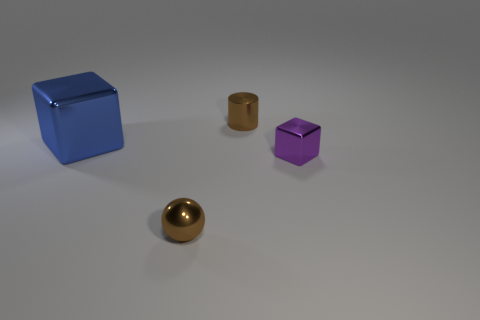Subtract all purple blocks. How many blocks are left? 1 Add 4 purple shiny things. How many objects exist? 8 Subtract all cylinders. How many objects are left? 3 Subtract all tiny balls. Subtract all tiny spheres. How many objects are left? 2 Add 3 purple things. How many purple things are left? 4 Add 4 blue metallic cubes. How many blue metallic cubes exist? 5 Subtract 0 yellow cubes. How many objects are left? 4 Subtract all gray blocks. Subtract all cyan balls. How many blocks are left? 2 Subtract all purple cylinders. How many blue blocks are left? 1 